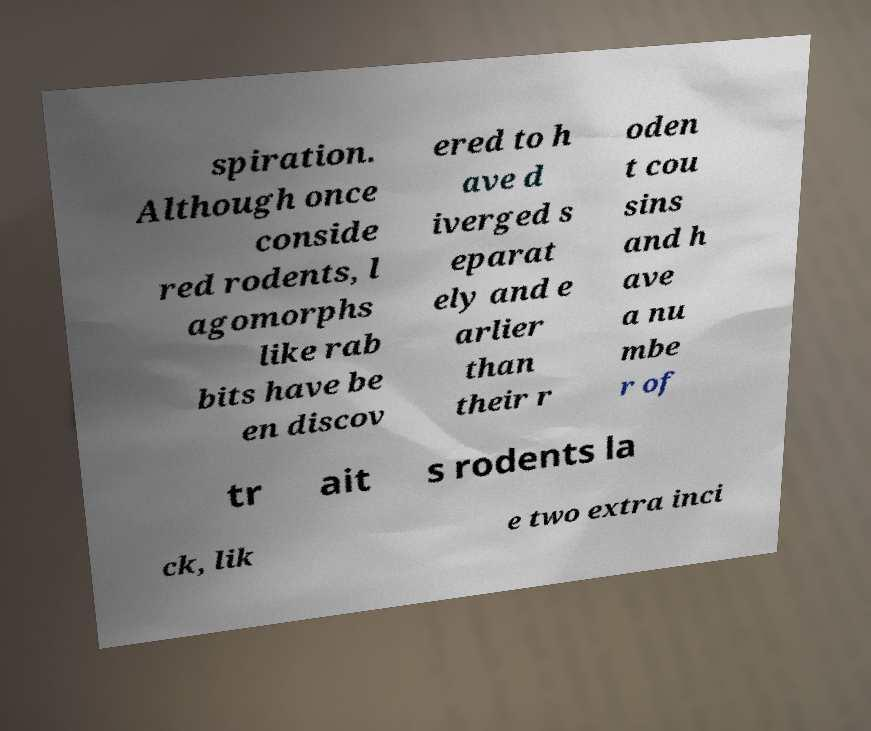What messages or text are displayed in this image? I need them in a readable, typed format. spiration. Although once conside red rodents, l agomorphs like rab bits have be en discov ered to h ave d iverged s eparat ely and e arlier than their r oden t cou sins and h ave a nu mbe r of tr ait s rodents la ck, lik e two extra inci 